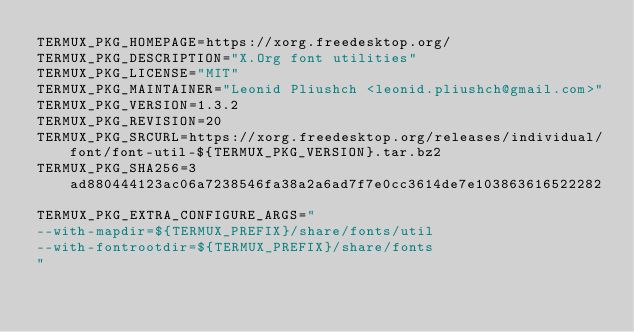<code> <loc_0><loc_0><loc_500><loc_500><_Bash_>TERMUX_PKG_HOMEPAGE=https://xorg.freedesktop.org/
TERMUX_PKG_DESCRIPTION="X.Org font utilities"
TERMUX_PKG_LICENSE="MIT"
TERMUX_PKG_MAINTAINER="Leonid Pliushch <leonid.pliushch@gmail.com>"
TERMUX_PKG_VERSION=1.3.2
TERMUX_PKG_REVISION=20
TERMUX_PKG_SRCURL=https://xorg.freedesktop.org/releases/individual/font/font-util-${TERMUX_PKG_VERSION}.tar.bz2
TERMUX_PKG_SHA256=3ad880444123ac06a7238546fa38a2a6ad7f7e0cc3614de7e103863616522282

TERMUX_PKG_EXTRA_CONFIGURE_ARGS="
--with-mapdir=${TERMUX_PREFIX}/share/fonts/util
--with-fontrootdir=${TERMUX_PREFIX}/share/fonts
"
</code> 